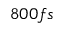<formula> <loc_0><loc_0><loc_500><loc_500>8 0 0 f s</formula> 